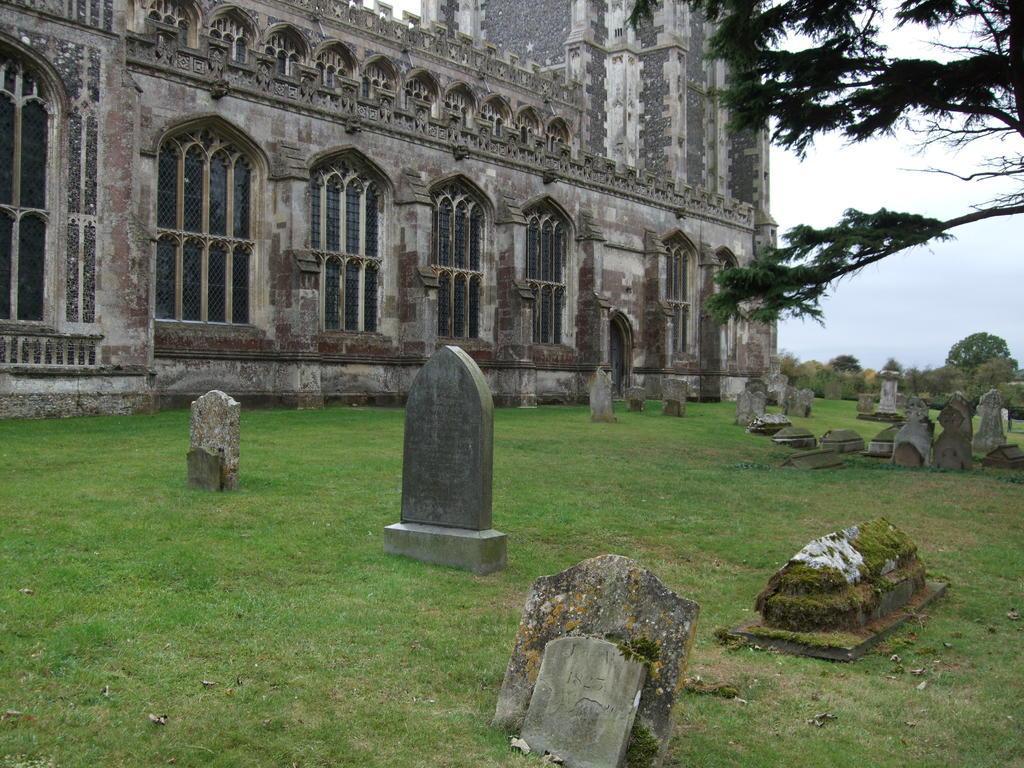Could you give a brief overview of what you see in this image? In this image there is a building, in front of the building there is a graveyard. On the right side of the image there is a tree. In the background there is a sky. 